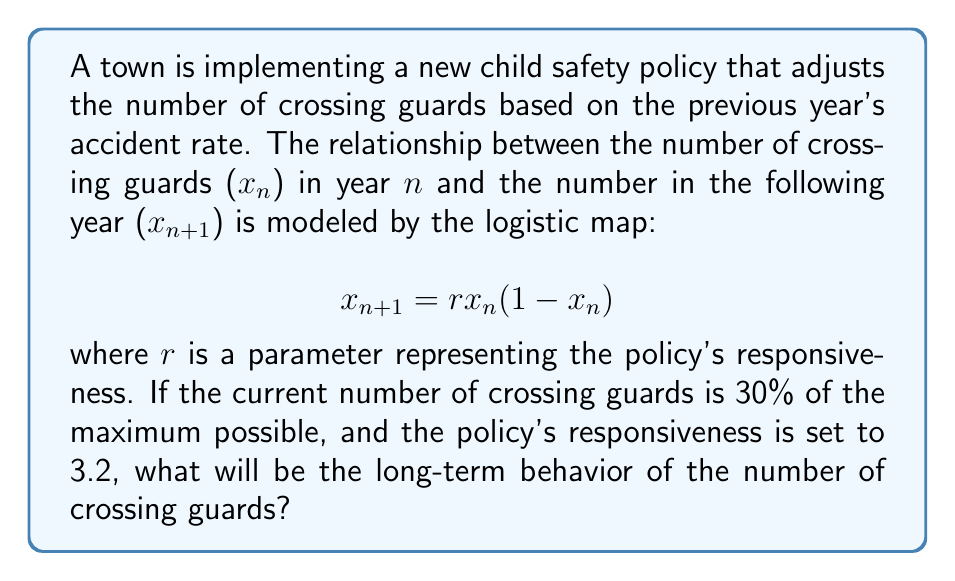Teach me how to tackle this problem. To analyze the long-term behavior of the crossing guard numbers, we need to examine the bifurcation diagram of the logistic map for the given parameters.

Step 1: Identify the initial condition and parameter values.
Initial condition: $x_0 = 0.3$ (30% of maximum)
Parameter: $r = 3.2$

Step 2: Iterate the logistic map equation.
$$x_{n+1} = 3.2x_n(1-x_n)$$

Step 3: Analyze the behavior for $r = 3.2$ on the bifurcation diagram.
[asy]
size(200,150);
import graph;

real f(real x, real r) {
  return r*x*(1-x);
}

for (real r = 2.5; r <= 4; r += 0.005) {
  real x = 0.5;
  for (int i = 0; i < 100; ++i) {
    x = f(x, r);
  }
  for (int i = 0; i < 100; ++i) {
    x = f(x, r);
    dot((r, x), rgb(0,0,1)+opacity(0.1));
  }
}

draw((2.5,0)--(4,0), arrow=Arrow);
draw((2.5,0)--(2.5,1), arrow=Arrow);

label("$r$", (4,0), E);
label("$x$", (2.5,1), N);

draw((3.2,0)--(3.2,1), rgb(1,0,0)+dashed);
[/asy]

Step 4: Interpret the diagram at $r = 3.2$.
The red dashed line at $r = 3.2$ intersects the bifurcation diagram at two points, indicating a period-2 orbit.

Step 5: Calculate the exact values of the period-2 orbit.
Solve the equation: $x = 3.2x(1-x)$
This yields two stable points: $x_1 \approx 0.7994$ and $x_2 \approx 0.5130$

Therefore, the long-term behavior will oscillate between these two values, representing about 79.94% and 51.30% of the maximum number of crossing guards in alternating years.
Answer: Period-2 oscillation between 79.94% and 51.30% of maximum 